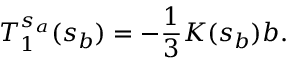<formula> <loc_0><loc_0><loc_500><loc_500>T _ { 1 } ^ { s _ { a } } ( s _ { b } ) = - { \frac { 1 } { 3 } } K ( s _ { b } ) b .</formula> 